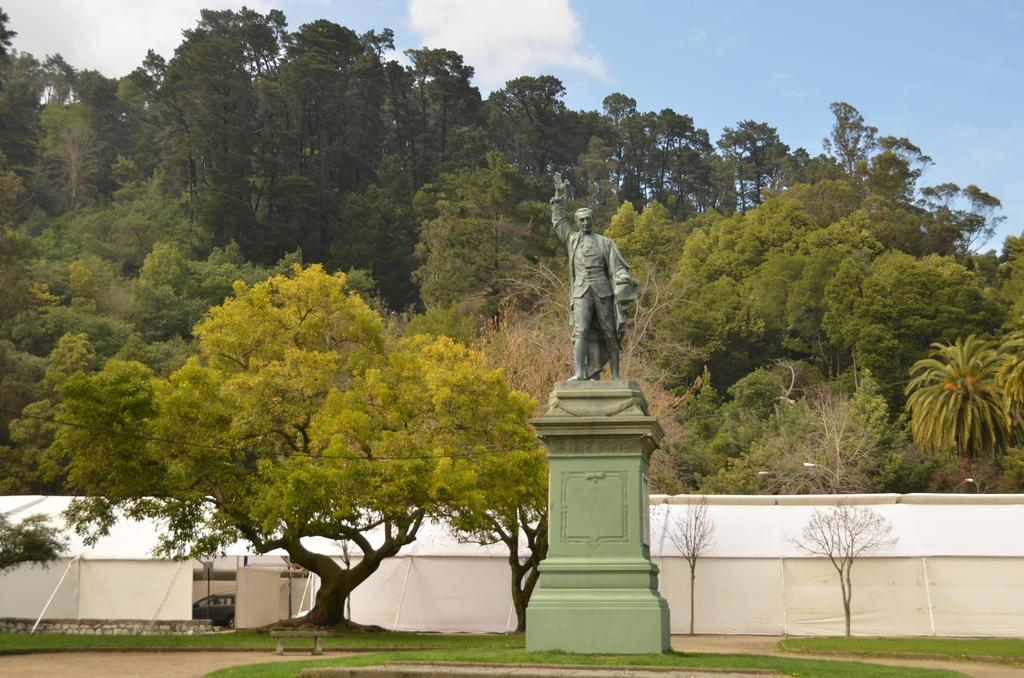What is the main subject in the image? There is a statue in the image. What can be seen in the background of the image? There are tents, trees, and a car in the background of the image. How many times do the sisters sneeze during the week in the image? There are no sisters or any indication of sneezing in the image. 